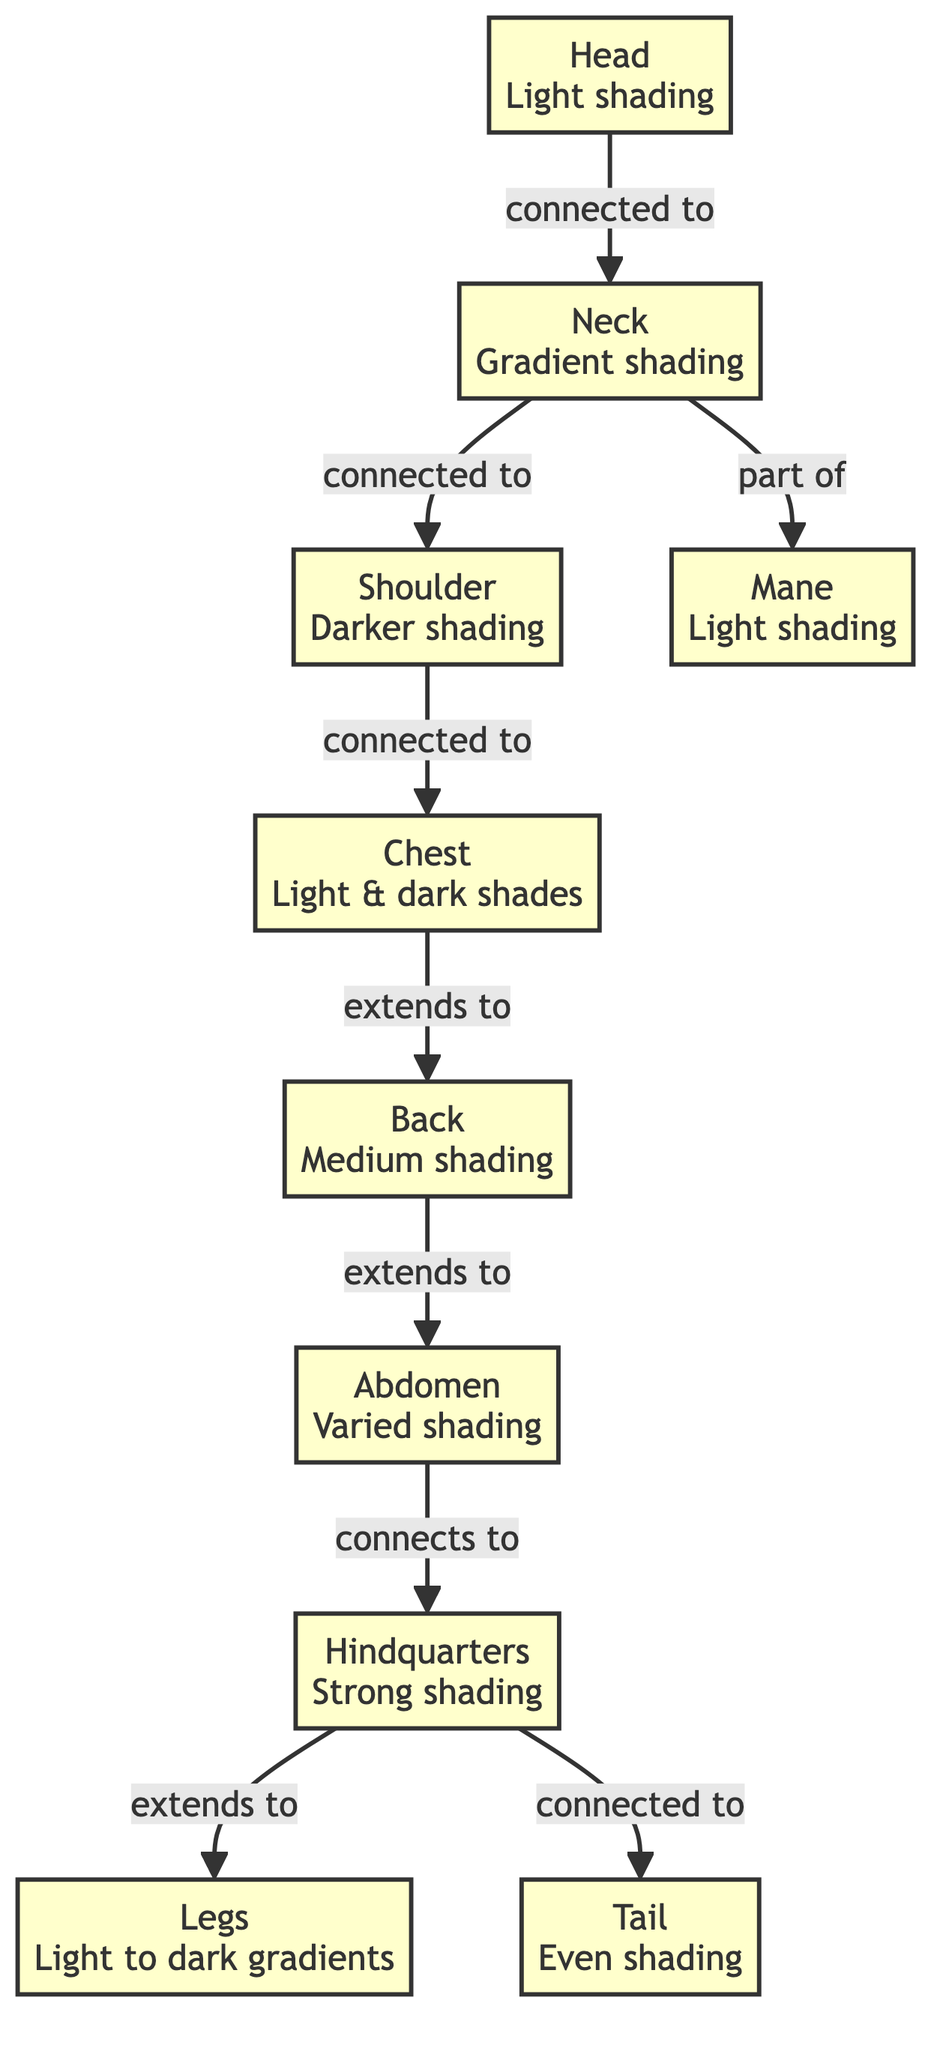What's the shading type of the head? The head is labeled with "Light shading" in the diagram, indicating the specific shading type associated with it.
Answer: Light shading How many nodes represent the horse's anatomy in the diagram? There are ten nodes total: head, neck, shoulder, chest, back, abdomen, hindquarters, legs, mane, and tail.
Answer: Ten nodes Which part of the horse is connected to the shoulder? The diagram shows that the chest is connected to the shoulder, indicating the structural relationship between these parts.
Answer: Chest What type of shading is applied to the abdomen? The abdomen has "Varied shading" which signifies a mix of different shading techniques to represent its anatomical features.
Answer: Varied shading Which part of the horse has a gradient shading style? The neck is specifically noted for "Gradient shading," indicating a transition of color within that section.
Answer: Gradient shading What shading type is associated with the hindquarters? The hindquarters are described as having "Strong shading," denoting a more pronounced shading technique for this area.
Answer: Strong shading Which two anatomical parts are connected to the tail in the diagram? The tail is connected to both the hindquarters and it elaborates on the connection of the horse's anatomy, emphasizing its position.
Answer: Hindquarters Is the mane part of any other anatomical node? Yes, the mane is indicated to be part of the neck node, showing that it directly connects to the anatomy of the horse.
Answer: Neck How does the back connect to other parts in the diagram? The back extends from the chest and further connects to the abdomen, illustrating a clear flow from the front to the rear of the horse's body.
Answer: Abdomen 